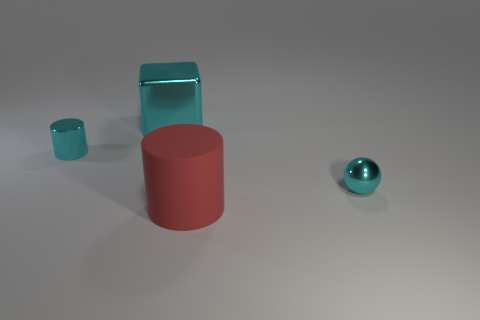There is another cyan thing that is the same shape as the large rubber thing; what is its material?
Your response must be concise. Metal. How big is the object in front of the object that is right of the large red cylinder?
Make the answer very short. Large. Are any metal things visible?
Your answer should be very brief. Yes. What material is the object that is both on the right side of the large cyan block and behind the red thing?
Your answer should be compact. Metal. Are there more cyan metallic things to the right of the large red cylinder than large red matte cylinders that are on the left side of the small cyan shiny sphere?
Provide a short and direct response. No. Are there any cyan things that have the same size as the ball?
Provide a succinct answer. Yes. What is the size of the cylinder that is right of the tiny cyan metal object left of the tiny cyan thing right of the red cylinder?
Give a very brief answer. Large. What color is the matte cylinder?
Your response must be concise. Red. Are there more tiny cyan metallic things in front of the large red rubber cylinder than gray cubes?
Offer a terse response. No. There is a big red rubber cylinder; what number of tiny cyan balls are to the right of it?
Your answer should be very brief. 1. 